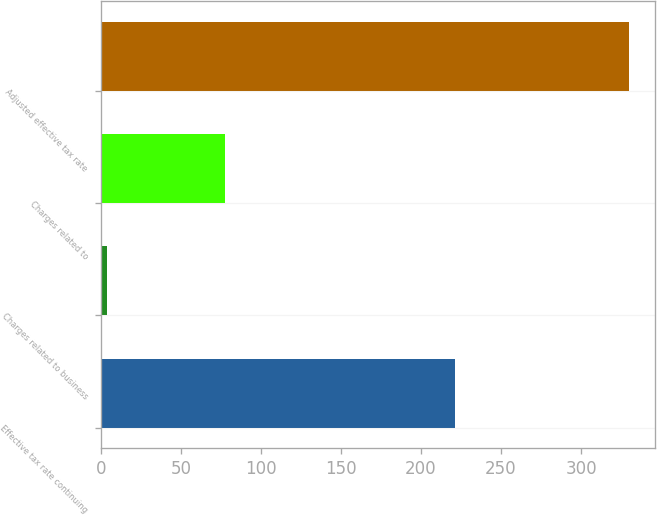<chart> <loc_0><loc_0><loc_500><loc_500><bar_chart><fcel>Effective tax rate continuing<fcel>Charges related to business<fcel>Charges related to<fcel>Adjusted effective tax rate<nl><fcel>221<fcel>4<fcel>77.6<fcel>330<nl></chart> 